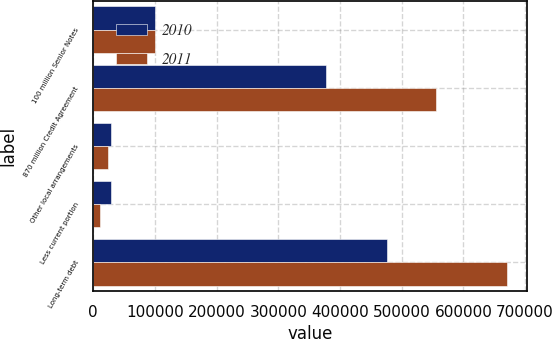Convert chart to OTSL. <chart><loc_0><loc_0><loc_500><loc_500><stacked_bar_chart><ecel><fcel>100 million Senior Notes<fcel>870 million Credit Agreement<fcel>Other local arrangements<fcel>Less current portion<fcel>Long-term debt<nl><fcel>2010<fcel>100000<fcel>376715<fcel>28300<fcel>28300<fcel>476715<nl><fcel>2011<fcel>100000<fcel>556481<fcel>24722<fcel>10902<fcel>670301<nl></chart> 